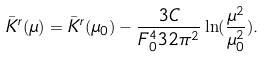<formula> <loc_0><loc_0><loc_500><loc_500>\bar { K } ^ { r } ( \mu ) = \bar { K } ^ { r } ( \mu _ { 0 } ) - \frac { 3 C } { F ^ { 4 } _ { 0 } 3 2 \pi ^ { 2 } } \ln ( \frac { \mu ^ { 2 } } { \mu ^ { 2 } _ { 0 } } ) .</formula> 